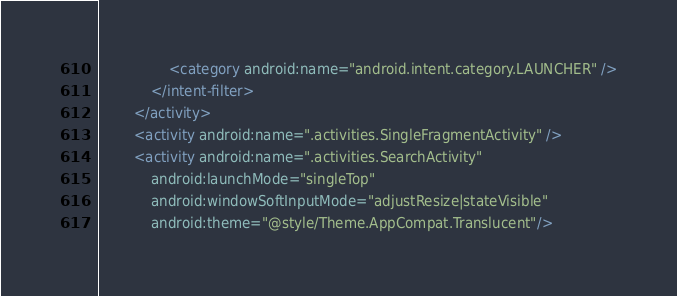Convert code to text. <code><loc_0><loc_0><loc_500><loc_500><_XML_>                <category android:name="android.intent.category.LAUNCHER" />
            </intent-filter>
        </activity>
        <activity android:name=".activities.SingleFragmentActivity" />
        <activity android:name=".activities.SearchActivity"
            android:launchMode="singleTop"
            android:windowSoftInputMode="adjustResize|stateVisible"
            android:theme="@style/Theme.AppCompat.Translucent"/>
</code> 